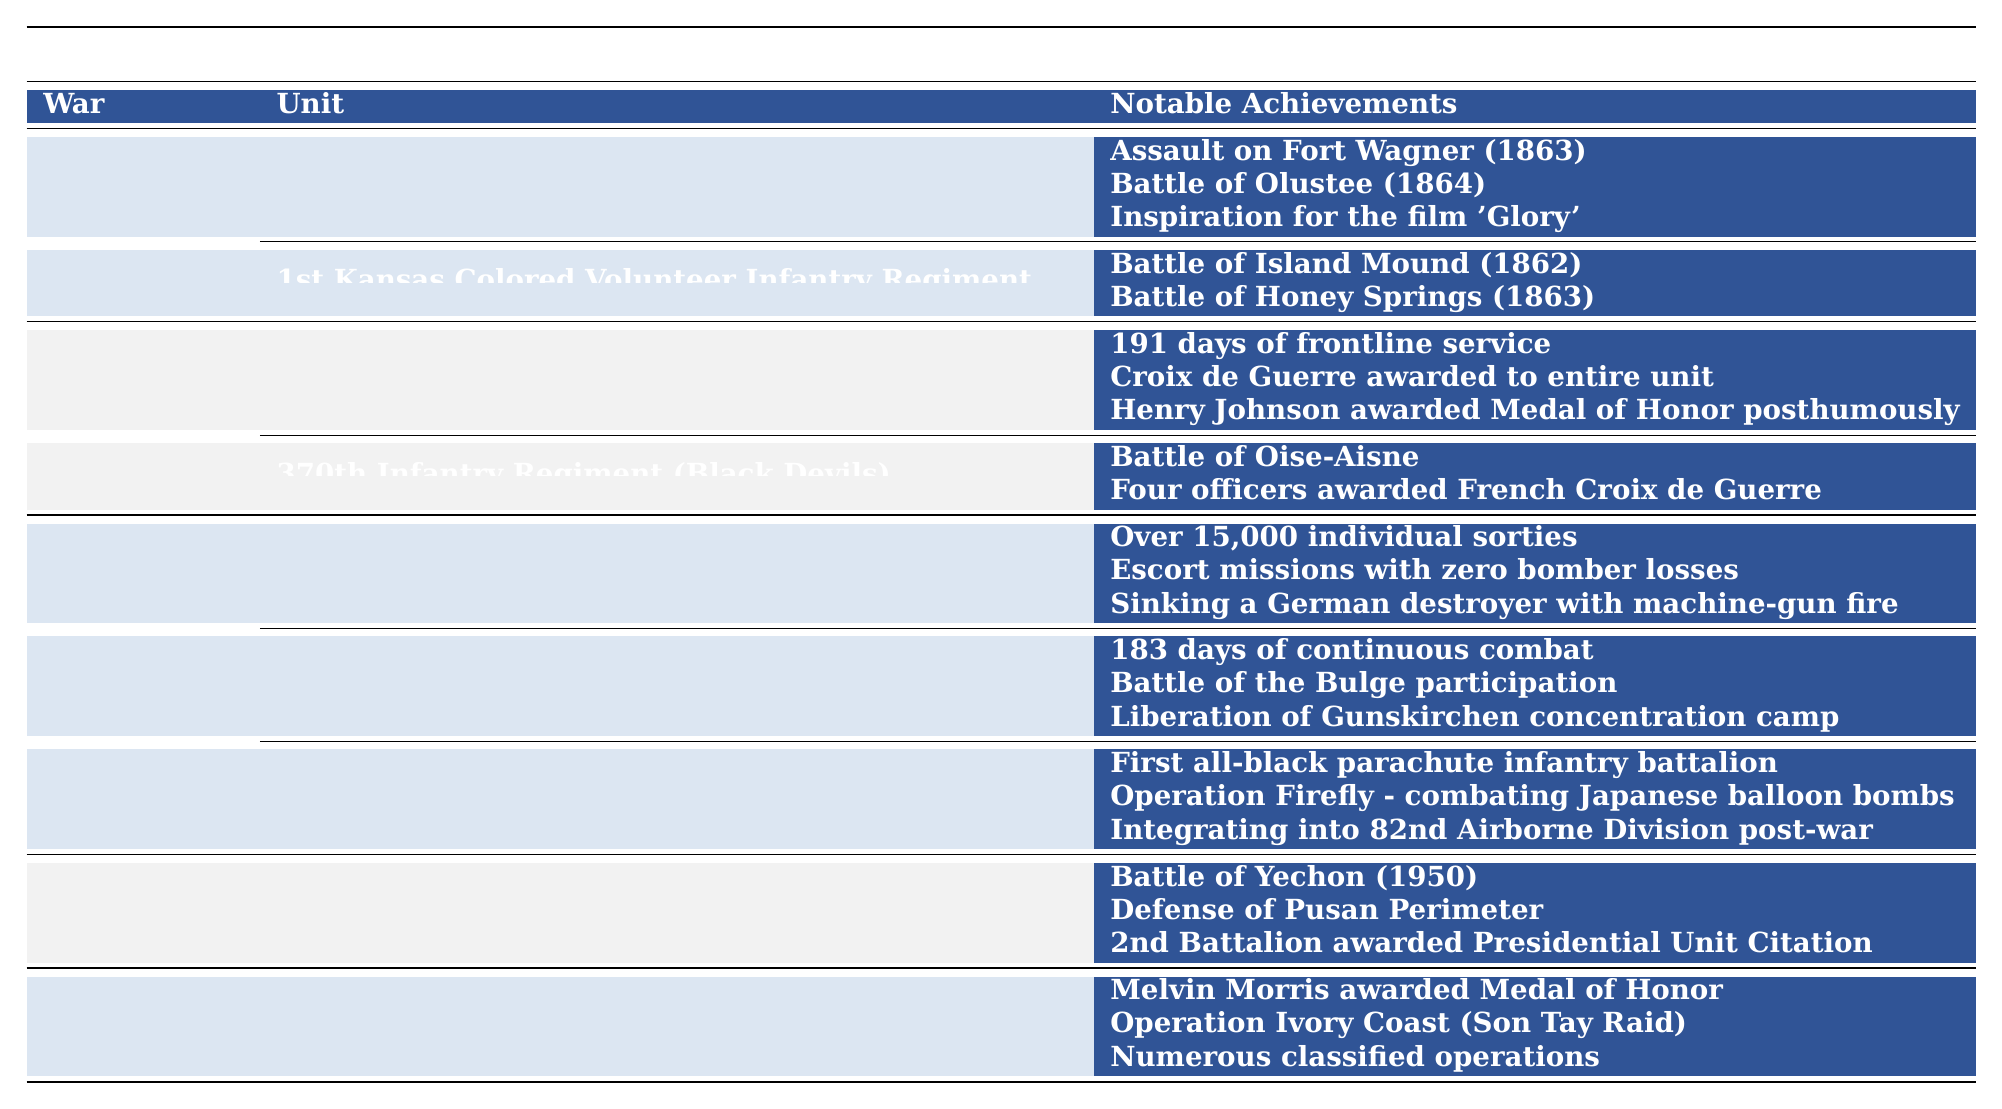What unit participated in the Battle of Olustee? The table lists the 1st Kansas Colored Volunteer Infantry Regiment as one of the units, and it specifically notes that it participated in the Battle of Olustee in 1864 under the Civil War section.
Answer: 1st Kansas Colored Volunteer Infantry Regiment How many notable achievements are listed for the 369th Infantry Regiment? Referring to the table, the 369th Infantry Regiment has three notable achievements listed: 191 days of frontline service, Croix de Guerre awarded to the entire unit, and Henry Johnson awarded Medal of Honor posthumously.
Answer: 3 Which war featured the first all-black parachute infantry battalion? The table indicates that the 555th Parachute Infantry Battalion (Triple Nickles) was noted as the first all-black parachute infantry battalion under the World War II section.
Answer: World War II Which African American military unit fought in the Korean War? The table's Korean War section specifically identifies the 24th Infantry Regiment as the unit that fought during this war.
Answer: 24th Infantry Regiment Which unit is recognized for integrating into the 82nd Airborne Division after the war? According to the table, the 555th Parachute Infantry Battalion (Triple Nickles) is noted for integrating into the 82nd Airborne Division post-war among its achievements.
Answer: 555th Parachute Infantry Battalion How many distinct wars are mentioned in the table? By counting the distinct wars listed in the table (Civil War, World War I, World War II, Korean War, and Vietnam War), we find there are five wars mentioned.
Answer: 5 Which war had the most units listed in the table? The World War II section contains three units (332nd Fighter Group, 761st Tank Battalion, and 555th Parachute Infantry Battalion), making it the war with the most units listed.
Answer: World War II Did the 370th Infantry Regiment receive any French honors? Yes, the table notes that the 370th Infantry Regiment (Black Devils) had four officers awarded the French Croix de Guerre.
Answer: Yes How many days of continuous combat did the 761st Tank Battalion experience? The table states that the 761st Tank Battalion was involved in 183 days of continuous combat during World War II.
Answer: 183 days In which wars did units receive the Croix de Guerre? The 369th Infantry Regiment received the Croix de Guerre in World War I, and the 370th Infantry Regiment also received this honor during the same war. Thus, both units were recognized in World War I.
Answer: World War I What is the notable achievement of the 332nd Fighter Group regarding bomber losses? The table highlights that the 332nd Fighter Group (Tuskegee Airmen) had escort missions with zero bomber losses, marking a significant achievement.
Answer: Zero bomber losses Which units were involved in battles during the Vietnam War and what were their notable achievements? The table shows that the 5th Special Forces Group is the only unit mentioned for the Vietnam War, with notable achievements including Melvin Morris awarded Medal of Honor and involvement in Operation Ivory Coast.
Answer: 5th Special Forces Group, notable achievements include Medal of Honor and Operation Ivory Coast 